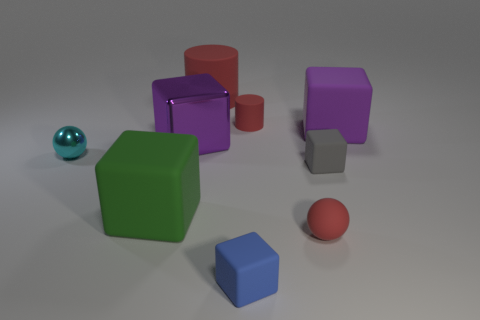Subtract all large purple shiny cubes. How many cubes are left? 4 Subtract 1 balls. How many balls are left? 1 Subtract all blue cubes. How many cubes are left? 4 Subtract 0 purple cylinders. How many objects are left? 9 Subtract all cubes. How many objects are left? 4 Subtract all cyan cubes. Subtract all purple spheres. How many cubes are left? 5 Subtract all red blocks. How many blue cylinders are left? 0 Subtract all large red metallic spheres. Subtract all tiny gray blocks. How many objects are left? 8 Add 9 metal blocks. How many metal blocks are left? 10 Add 1 green objects. How many green objects exist? 2 